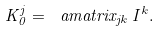Convert formula to latex. <formula><loc_0><loc_0><loc_500><loc_500>K ^ { j } _ { 0 } = \ a m a t r i x _ { j k } \, I ^ { k } .</formula> 